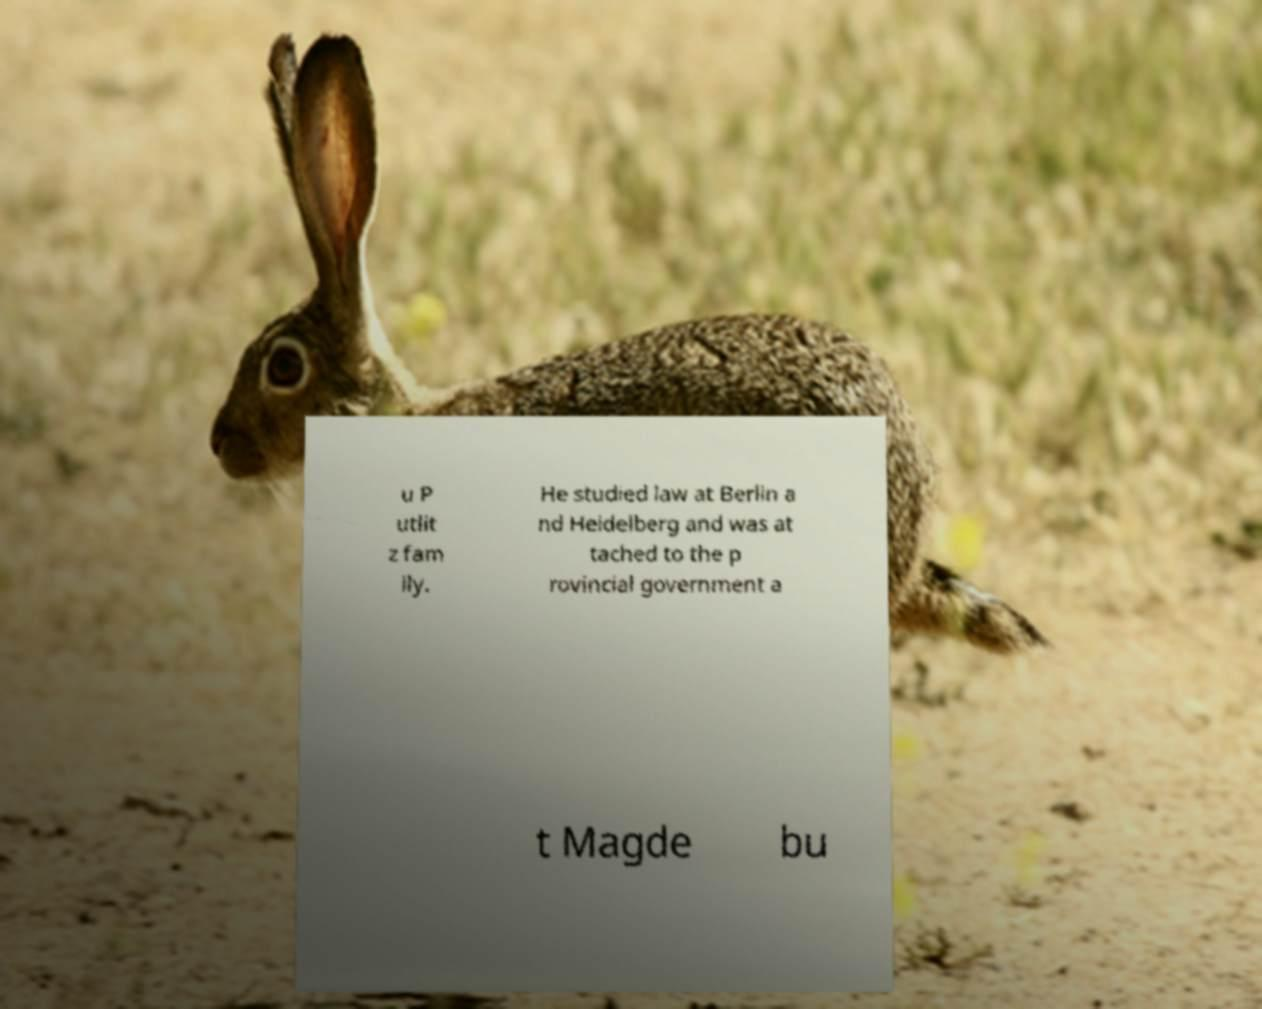I need the written content from this picture converted into text. Can you do that? u P utlit z fam ily. He studied law at Berlin a nd Heidelberg and was at tached to the p rovincial government a t Magde bu 